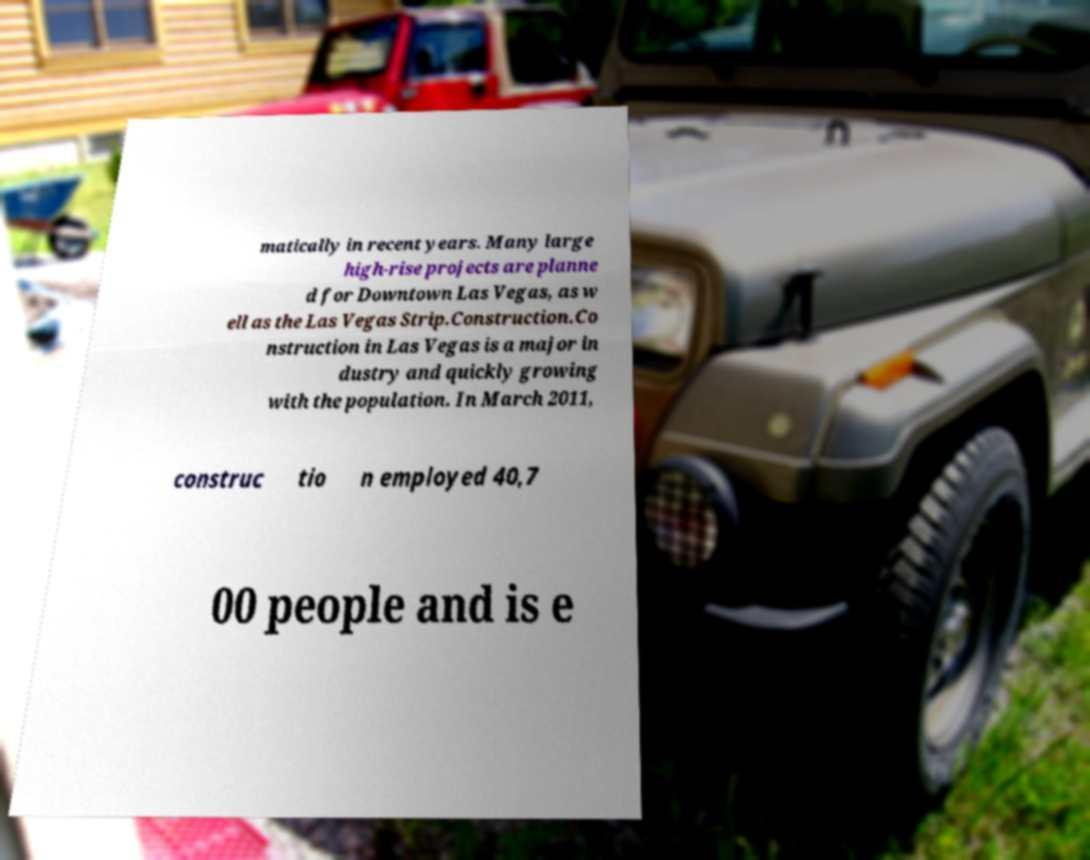I need the written content from this picture converted into text. Can you do that? matically in recent years. Many large high-rise projects are planne d for Downtown Las Vegas, as w ell as the Las Vegas Strip.Construction.Co nstruction in Las Vegas is a major in dustry and quickly growing with the population. In March 2011, construc tio n employed 40,7 00 people and is e 